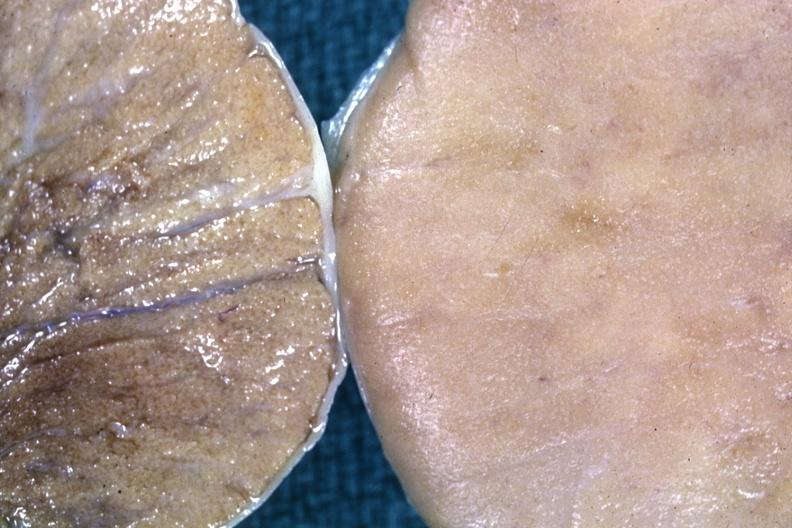does this image show fixed tissue contrast of normal cut surface with one having diffuse infiltrate?
Answer the question using a single word or phrase. Yes 